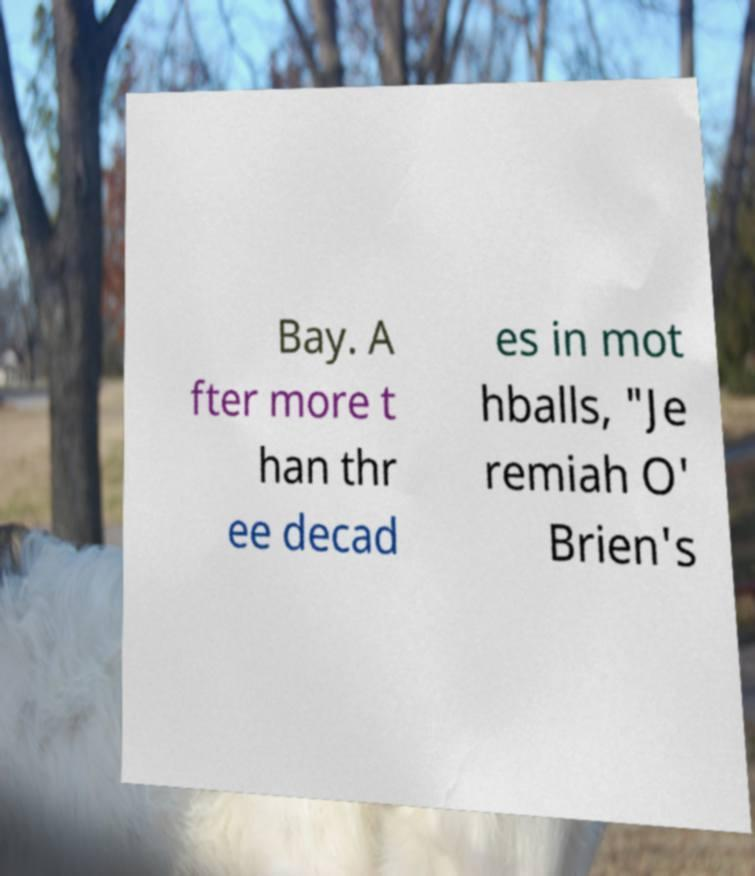Can you read and provide the text displayed in the image?This photo seems to have some interesting text. Can you extract and type it out for me? Bay. A fter more t han thr ee decad es in mot hballs, "Je remiah O' Brien's 